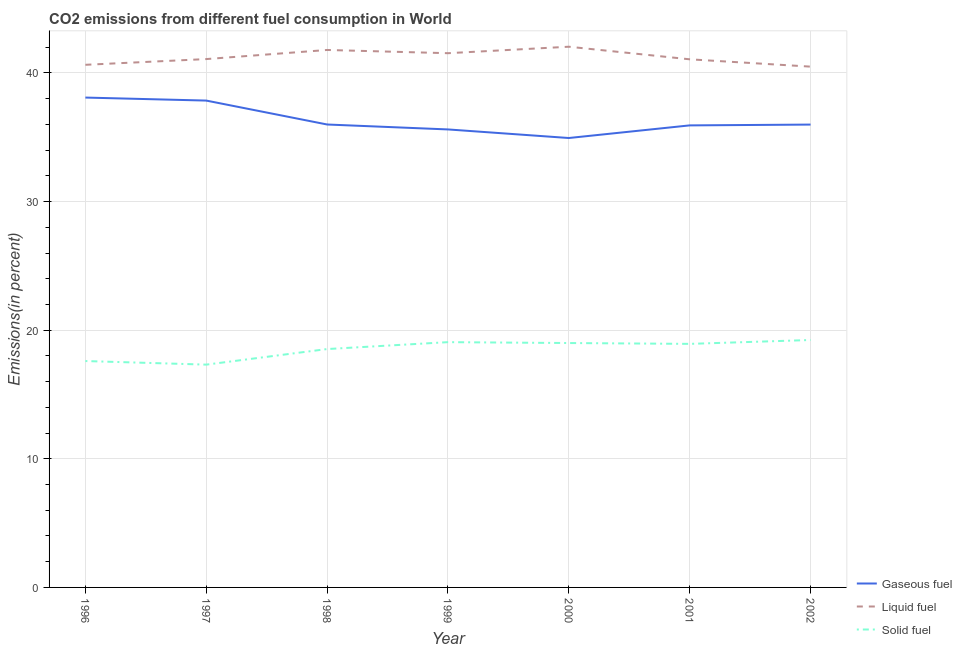What is the percentage of liquid fuel emission in 2000?
Offer a very short reply. 42.04. Across all years, what is the maximum percentage of gaseous fuel emission?
Provide a short and direct response. 38.08. Across all years, what is the minimum percentage of gaseous fuel emission?
Your answer should be compact. 34.94. What is the total percentage of gaseous fuel emission in the graph?
Provide a short and direct response. 254.38. What is the difference between the percentage of gaseous fuel emission in 2000 and that in 2002?
Keep it short and to the point. -1.04. What is the difference between the percentage of solid fuel emission in 1998 and the percentage of gaseous fuel emission in 2000?
Your answer should be compact. -16.41. What is the average percentage of gaseous fuel emission per year?
Provide a succinct answer. 36.34. In the year 1997, what is the difference between the percentage of gaseous fuel emission and percentage of liquid fuel emission?
Make the answer very short. -3.23. In how many years, is the percentage of liquid fuel emission greater than 32 %?
Provide a short and direct response. 7. What is the ratio of the percentage of gaseous fuel emission in 1999 to that in 2000?
Offer a very short reply. 1.02. Is the percentage of liquid fuel emission in 1996 less than that in 1997?
Make the answer very short. Yes. What is the difference between the highest and the second highest percentage of liquid fuel emission?
Provide a succinct answer. 0.25. What is the difference between the highest and the lowest percentage of gaseous fuel emission?
Your answer should be very brief. 3.14. In how many years, is the percentage of liquid fuel emission greater than the average percentage of liquid fuel emission taken over all years?
Your answer should be compact. 3. Is it the case that in every year, the sum of the percentage of gaseous fuel emission and percentage of liquid fuel emission is greater than the percentage of solid fuel emission?
Provide a short and direct response. Yes. Is the percentage of gaseous fuel emission strictly greater than the percentage of solid fuel emission over the years?
Make the answer very short. Yes. Is the percentage of liquid fuel emission strictly less than the percentage of solid fuel emission over the years?
Your response must be concise. No. How many years are there in the graph?
Provide a succinct answer. 7. Are the values on the major ticks of Y-axis written in scientific E-notation?
Give a very brief answer. No. Does the graph contain any zero values?
Your answer should be compact. No. Where does the legend appear in the graph?
Offer a very short reply. Bottom right. How are the legend labels stacked?
Keep it short and to the point. Vertical. What is the title of the graph?
Make the answer very short. CO2 emissions from different fuel consumption in World. Does "Unpaid family workers" appear as one of the legend labels in the graph?
Your answer should be very brief. No. What is the label or title of the X-axis?
Give a very brief answer. Year. What is the label or title of the Y-axis?
Offer a terse response. Emissions(in percent). What is the Emissions(in percent) in Gaseous fuel in 1996?
Offer a terse response. 38.08. What is the Emissions(in percent) of Liquid fuel in 1996?
Keep it short and to the point. 40.63. What is the Emissions(in percent) of Solid fuel in 1996?
Provide a succinct answer. 17.6. What is the Emissions(in percent) in Gaseous fuel in 1997?
Your answer should be very brief. 37.85. What is the Emissions(in percent) of Liquid fuel in 1997?
Provide a short and direct response. 41.08. What is the Emissions(in percent) in Solid fuel in 1997?
Make the answer very short. 17.32. What is the Emissions(in percent) in Gaseous fuel in 1998?
Keep it short and to the point. 35.99. What is the Emissions(in percent) in Liquid fuel in 1998?
Your answer should be compact. 41.79. What is the Emissions(in percent) in Solid fuel in 1998?
Ensure brevity in your answer.  18.53. What is the Emissions(in percent) of Gaseous fuel in 1999?
Make the answer very short. 35.61. What is the Emissions(in percent) of Liquid fuel in 1999?
Offer a terse response. 41.53. What is the Emissions(in percent) of Solid fuel in 1999?
Offer a very short reply. 19.07. What is the Emissions(in percent) in Gaseous fuel in 2000?
Your response must be concise. 34.94. What is the Emissions(in percent) of Liquid fuel in 2000?
Keep it short and to the point. 42.04. What is the Emissions(in percent) of Solid fuel in 2000?
Keep it short and to the point. 19. What is the Emissions(in percent) in Gaseous fuel in 2001?
Offer a terse response. 35.92. What is the Emissions(in percent) in Liquid fuel in 2001?
Your answer should be compact. 41.06. What is the Emissions(in percent) in Solid fuel in 2001?
Offer a very short reply. 18.93. What is the Emissions(in percent) in Gaseous fuel in 2002?
Keep it short and to the point. 35.98. What is the Emissions(in percent) in Liquid fuel in 2002?
Your answer should be compact. 40.49. What is the Emissions(in percent) in Solid fuel in 2002?
Offer a very short reply. 19.24. Across all years, what is the maximum Emissions(in percent) in Gaseous fuel?
Provide a succinct answer. 38.08. Across all years, what is the maximum Emissions(in percent) of Liquid fuel?
Ensure brevity in your answer.  42.04. Across all years, what is the maximum Emissions(in percent) of Solid fuel?
Your response must be concise. 19.24. Across all years, what is the minimum Emissions(in percent) of Gaseous fuel?
Your response must be concise. 34.94. Across all years, what is the minimum Emissions(in percent) in Liquid fuel?
Your response must be concise. 40.49. Across all years, what is the minimum Emissions(in percent) in Solid fuel?
Give a very brief answer. 17.32. What is the total Emissions(in percent) of Gaseous fuel in the graph?
Offer a terse response. 254.38. What is the total Emissions(in percent) of Liquid fuel in the graph?
Offer a terse response. 288.61. What is the total Emissions(in percent) in Solid fuel in the graph?
Ensure brevity in your answer.  129.7. What is the difference between the Emissions(in percent) in Gaseous fuel in 1996 and that in 1997?
Your response must be concise. 0.23. What is the difference between the Emissions(in percent) of Liquid fuel in 1996 and that in 1997?
Offer a very short reply. -0.45. What is the difference between the Emissions(in percent) of Solid fuel in 1996 and that in 1997?
Offer a very short reply. 0.28. What is the difference between the Emissions(in percent) of Gaseous fuel in 1996 and that in 1998?
Your response must be concise. 2.09. What is the difference between the Emissions(in percent) in Liquid fuel in 1996 and that in 1998?
Your answer should be compact. -1.15. What is the difference between the Emissions(in percent) in Solid fuel in 1996 and that in 1998?
Provide a succinct answer. -0.93. What is the difference between the Emissions(in percent) of Gaseous fuel in 1996 and that in 1999?
Your answer should be compact. 2.48. What is the difference between the Emissions(in percent) of Liquid fuel in 1996 and that in 1999?
Your answer should be compact. -0.9. What is the difference between the Emissions(in percent) in Solid fuel in 1996 and that in 1999?
Your answer should be very brief. -1.47. What is the difference between the Emissions(in percent) in Gaseous fuel in 1996 and that in 2000?
Your answer should be compact. 3.14. What is the difference between the Emissions(in percent) of Liquid fuel in 1996 and that in 2000?
Ensure brevity in your answer.  -1.41. What is the difference between the Emissions(in percent) in Gaseous fuel in 1996 and that in 2001?
Ensure brevity in your answer.  2.16. What is the difference between the Emissions(in percent) in Liquid fuel in 1996 and that in 2001?
Offer a very short reply. -0.43. What is the difference between the Emissions(in percent) of Solid fuel in 1996 and that in 2001?
Your response must be concise. -1.33. What is the difference between the Emissions(in percent) of Gaseous fuel in 1996 and that in 2002?
Give a very brief answer. 2.1. What is the difference between the Emissions(in percent) in Liquid fuel in 1996 and that in 2002?
Your answer should be compact. 0.14. What is the difference between the Emissions(in percent) of Solid fuel in 1996 and that in 2002?
Provide a succinct answer. -1.64. What is the difference between the Emissions(in percent) of Gaseous fuel in 1997 and that in 1998?
Your response must be concise. 1.86. What is the difference between the Emissions(in percent) in Liquid fuel in 1997 and that in 1998?
Make the answer very short. -0.71. What is the difference between the Emissions(in percent) of Solid fuel in 1997 and that in 1998?
Your answer should be compact. -1.21. What is the difference between the Emissions(in percent) of Gaseous fuel in 1997 and that in 1999?
Your answer should be compact. 2.24. What is the difference between the Emissions(in percent) in Liquid fuel in 1997 and that in 1999?
Ensure brevity in your answer.  -0.46. What is the difference between the Emissions(in percent) of Solid fuel in 1997 and that in 1999?
Keep it short and to the point. -1.75. What is the difference between the Emissions(in percent) in Gaseous fuel in 1997 and that in 2000?
Provide a succinct answer. 2.91. What is the difference between the Emissions(in percent) in Liquid fuel in 1997 and that in 2000?
Your answer should be very brief. -0.96. What is the difference between the Emissions(in percent) of Solid fuel in 1997 and that in 2000?
Your answer should be very brief. -1.68. What is the difference between the Emissions(in percent) of Gaseous fuel in 1997 and that in 2001?
Your response must be concise. 1.93. What is the difference between the Emissions(in percent) in Liquid fuel in 1997 and that in 2001?
Make the answer very short. 0.02. What is the difference between the Emissions(in percent) of Solid fuel in 1997 and that in 2001?
Your answer should be compact. -1.61. What is the difference between the Emissions(in percent) in Gaseous fuel in 1997 and that in 2002?
Provide a short and direct response. 1.87. What is the difference between the Emissions(in percent) in Liquid fuel in 1997 and that in 2002?
Offer a very short reply. 0.59. What is the difference between the Emissions(in percent) of Solid fuel in 1997 and that in 2002?
Give a very brief answer. -1.91. What is the difference between the Emissions(in percent) in Gaseous fuel in 1998 and that in 1999?
Your response must be concise. 0.38. What is the difference between the Emissions(in percent) of Liquid fuel in 1998 and that in 1999?
Your answer should be very brief. 0.25. What is the difference between the Emissions(in percent) in Solid fuel in 1998 and that in 1999?
Give a very brief answer. -0.54. What is the difference between the Emissions(in percent) in Gaseous fuel in 1998 and that in 2000?
Your answer should be very brief. 1.05. What is the difference between the Emissions(in percent) in Liquid fuel in 1998 and that in 2000?
Offer a terse response. -0.25. What is the difference between the Emissions(in percent) in Solid fuel in 1998 and that in 2000?
Offer a terse response. -0.47. What is the difference between the Emissions(in percent) in Gaseous fuel in 1998 and that in 2001?
Provide a short and direct response. 0.07. What is the difference between the Emissions(in percent) of Liquid fuel in 1998 and that in 2001?
Ensure brevity in your answer.  0.73. What is the difference between the Emissions(in percent) of Solid fuel in 1998 and that in 2001?
Offer a terse response. -0.4. What is the difference between the Emissions(in percent) in Gaseous fuel in 1998 and that in 2002?
Offer a terse response. 0.01. What is the difference between the Emissions(in percent) in Liquid fuel in 1998 and that in 2002?
Keep it short and to the point. 1.3. What is the difference between the Emissions(in percent) of Solid fuel in 1998 and that in 2002?
Ensure brevity in your answer.  -0.7. What is the difference between the Emissions(in percent) in Gaseous fuel in 1999 and that in 2000?
Offer a terse response. 0.67. What is the difference between the Emissions(in percent) of Liquid fuel in 1999 and that in 2000?
Provide a short and direct response. -0.5. What is the difference between the Emissions(in percent) in Solid fuel in 1999 and that in 2000?
Provide a short and direct response. 0.07. What is the difference between the Emissions(in percent) in Gaseous fuel in 1999 and that in 2001?
Offer a very short reply. -0.31. What is the difference between the Emissions(in percent) in Liquid fuel in 1999 and that in 2001?
Your answer should be compact. 0.47. What is the difference between the Emissions(in percent) of Solid fuel in 1999 and that in 2001?
Ensure brevity in your answer.  0.13. What is the difference between the Emissions(in percent) in Gaseous fuel in 1999 and that in 2002?
Provide a short and direct response. -0.38. What is the difference between the Emissions(in percent) of Liquid fuel in 1999 and that in 2002?
Give a very brief answer. 1.04. What is the difference between the Emissions(in percent) of Solid fuel in 1999 and that in 2002?
Your answer should be very brief. -0.17. What is the difference between the Emissions(in percent) in Gaseous fuel in 2000 and that in 2001?
Keep it short and to the point. -0.98. What is the difference between the Emissions(in percent) of Liquid fuel in 2000 and that in 2001?
Offer a terse response. 0.98. What is the difference between the Emissions(in percent) of Solid fuel in 2000 and that in 2001?
Your response must be concise. 0.07. What is the difference between the Emissions(in percent) of Gaseous fuel in 2000 and that in 2002?
Offer a very short reply. -1.04. What is the difference between the Emissions(in percent) in Liquid fuel in 2000 and that in 2002?
Your answer should be compact. 1.55. What is the difference between the Emissions(in percent) of Solid fuel in 2000 and that in 2002?
Offer a terse response. -0.24. What is the difference between the Emissions(in percent) in Gaseous fuel in 2001 and that in 2002?
Your response must be concise. -0.06. What is the difference between the Emissions(in percent) of Liquid fuel in 2001 and that in 2002?
Offer a terse response. 0.57. What is the difference between the Emissions(in percent) in Solid fuel in 2001 and that in 2002?
Your response must be concise. -0.3. What is the difference between the Emissions(in percent) in Gaseous fuel in 1996 and the Emissions(in percent) in Liquid fuel in 1997?
Give a very brief answer. -2.99. What is the difference between the Emissions(in percent) in Gaseous fuel in 1996 and the Emissions(in percent) in Solid fuel in 1997?
Provide a short and direct response. 20.76. What is the difference between the Emissions(in percent) in Liquid fuel in 1996 and the Emissions(in percent) in Solid fuel in 1997?
Make the answer very short. 23.31. What is the difference between the Emissions(in percent) in Gaseous fuel in 1996 and the Emissions(in percent) in Liquid fuel in 1998?
Your answer should be very brief. -3.7. What is the difference between the Emissions(in percent) of Gaseous fuel in 1996 and the Emissions(in percent) of Solid fuel in 1998?
Give a very brief answer. 19.55. What is the difference between the Emissions(in percent) of Liquid fuel in 1996 and the Emissions(in percent) of Solid fuel in 1998?
Offer a terse response. 22.1. What is the difference between the Emissions(in percent) of Gaseous fuel in 1996 and the Emissions(in percent) of Liquid fuel in 1999?
Keep it short and to the point. -3.45. What is the difference between the Emissions(in percent) of Gaseous fuel in 1996 and the Emissions(in percent) of Solid fuel in 1999?
Provide a short and direct response. 19.02. What is the difference between the Emissions(in percent) in Liquid fuel in 1996 and the Emissions(in percent) in Solid fuel in 1999?
Offer a terse response. 21.56. What is the difference between the Emissions(in percent) in Gaseous fuel in 1996 and the Emissions(in percent) in Liquid fuel in 2000?
Your response must be concise. -3.95. What is the difference between the Emissions(in percent) of Gaseous fuel in 1996 and the Emissions(in percent) of Solid fuel in 2000?
Give a very brief answer. 19.08. What is the difference between the Emissions(in percent) of Liquid fuel in 1996 and the Emissions(in percent) of Solid fuel in 2000?
Your response must be concise. 21.63. What is the difference between the Emissions(in percent) of Gaseous fuel in 1996 and the Emissions(in percent) of Liquid fuel in 2001?
Give a very brief answer. -2.97. What is the difference between the Emissions(in percent) in Gaseous fuel in 1996 and the Emissions(in percent) in Solid fuel in 2001?
Ensure brevity in your answer.  19.15. What is the difference between the Emissions(in percent) in Liquid fuel in 1996 and the Emissions(in percent) in Solid fuel in 2001?
Offer a terse response. 21.7. What is the difference between the Emissions(in percent) in Gaseous fuel in 1996 and the Emissions(in percent) in Liquid fuel in 2002?
Ensure brevity in your answer.  -2.4. What is the difference between the Emissions(in percent) in Gaseous fuel in 1996 and the Emissions(in percent) in Solid fuel in 2002?
Provide a succinct answer. 18.85. What is the difference between the Emissions(in percent) in Liquid fuel in 1996 and the Emissions(in percent) in Solid fuel in 2002?
Ensure brevity in your answer.  21.4. What is the difference between the Emissions(in percent) of Gaseous fuel in 1997 and the Emissions(in percent) of Liquid fuel in 1998?
Your answer should be very brief. -3.93. What is the difference between the Emissions(in percent) of Gaseous fuel in 1997 and the Emissions(in percent) of Solid fuel in 1998?
Offer a very short reply. 19.32. What is the difference between the Emissions(in percent) of Liquid fuel in 1997 and the Emissions(in percent) of Solid fuel in 1998?
Your answer should be compact. 22.54. What is the difference between the Emissions(in percent) of Gaseous fuel in 1997 and the Emissions(in percent) of Liquid fuel in 1999?
Offer a terse response. -3.68. What is the difference between the Emissions(in percent) in Gaseous fuel in 1997 and the Emissions(in percent) in Solid fuel in 1999?
Keep it short and to the point. 18.78. What is the difference between the Emissions(in percent) of Liquid fuel in 1997 and the Emissions(in percent) of Solid fuel in 1999?
Make the answer very short. 22.01. What is the difference between the Emissions(in percent) of Gaseous fuel in 1997 and the Emissions(in percent) of Liquid fuel in 2000?
Offer a terse response. -4.19. What is the difference between the Emissions(in percent) in Gaseous fuel in 1997 and the Emissions(in percent) in Solid fuel in 2000?
Provide a short and direct response. 18.85. What is the difference between the Emissions(in percent) of Liquid fuel in 1997 and the Emissions(in percent) of Solid fuel in 2000?
Give a very brief answer. 22.08. What is the difference between the Emissions(in percent) of Gaseous fuel in 1997 and the Emissions(in percent) of Liquid fuel in 2001?
Offer a very short reply. -3.21. What is the difference between the Emissions(in percent) in Gaseous fuel in 1997 and the Emissions(in percent) in Solid fuel in 2001?
Make the answer very short. 18.92. What is the difference between the Emissions(in percent) of Liquid fuel in 1997 and the Emissions(in percent) of Solid fuel in 2001?
Your response must be concise. 22.14. What is the difference between the Emissions(in percent) of Gaseous fuel in 1997 and the Emissions(in percent) of Liquid fuel in 2002?
Your answer should be compact. -2.64. What is the difference between the Emissions(in percent) of Gaseous fuel in 1997 and the Emissions(in percent) of Solid fuel in 2002?
Your answer should be very brief. 18.61. What is the difference between the Emissions(in percent) of Liquid fuel in 1997 and the Emissions(in percent) of Solid fuel in 2002?
Your response must be concise. 21.84. What is the difference between the Emissions(in percent) of Gaseous fuel in 1998 and the Emissions(in percent) of Liquid fuel in 1999?
Your answer should be compact. -5.54. What is the difference between the Emissions(in percent) in Gaseous fuel in 1998 and the Emissions(in percent) in Solid fuel in 1999?
Give a very brief answer. 16.92. What is the difference between the Emissions(in percent) of Liquid fuel in 1998 and the Emissions(in percent) of Solid fuel in 1999?
Provide a short and direct response. 22.72. What is the difference between the Emissions(in percent) of Gaseous fuel in 1998 and the Emissions(in percent) of Liquid fuel in 2000?
Your answer should be compact. -6.05. What is the difference between the Emissions(in percent) of Gaseous fuel in 1998 and the Emissions(in percent) of Solid fuel in 2000?
Your answer should be compact. 16.99. What is the difference between the Emissions(in percent) of Liquid fuel in 1998 and the Emissions(in percent) of Solid fuel in 2000?
Give a very brief answer. 22.78. What is the difference between the Emissions(in percent) of Gaseous fuel in 1998 and the Emissions(in percent) of Liquid fuel in 2001?
Make the answer very short. -5.07. What is the difference between the Emissions(in percent) of Gaseous fuel in 1998 and the Emissions(in percent) of Solid fuel in 2001?
Provide a succinct answer. 17.06. What is the difference between the Emissions(in percent) of Liquid fuel in 1998 and the Emissions(in percent) of Solid fuel in 2001?
Ensure brevity in your answer.  22.85. What is the difference between the Emissions(in percent) in Gaseous fuel in 1998 and the Emissions(in percent) in Liquid fuel in 2002?
Your response must be concise. -4.5. What is the difference between the Emissions(in percent) in Gaseous fuel in 1998 and the Emissions(in percent) in Solid fuel in 2002?
Your response must be concise. 16.75. What is the difference between the Emissions(in percent) in Liquid fuel in 1998 and the Emissions(in percent) in Solid fuel in 2002?
Your response must be concise. 22.55. What is the difference between the Emissions(in percent) of Gaseous fuel in 1999 and the Emissions(in percent) of Liquid fuel in 2000?
Ensure brevity in your answer.  -6.43. What is the difference between the Emissions(in percent) of Gaseous fuel in 1999 and the Emissions(in percent) of Solid fuel in 2000?
Give a very brief answer. 16.61. What is the difference between the Emissions(in percent) of Liquid fuel in 1999 and the Emissions(in percent) of Solid fuel in 2000?
Give a very brief answer. 22.53. What is the difference between the Emissions(in percent) of Gaseous fuel in 1999 and the Emissions(in percent) of Liquid fuel in 2001?
Provide a succinct answer. -5.45. What is the difference between the Emissions(in percent) in Gaseous fuel in 1999 and the Emissions(in percent) in Solid fuel in 2001?
Keep it short and to the point. 16.67. What is the difference between the Emissions(in percent) of Liquid fuel in 1999 and the Emissions(in percent) of Solid fuel in 2001?
Provide a short and direct response. 22.6. What is the difference between the Emissions(in percent) in Gaseous fuel in 1999 and the Emissions(in percent) in Liquid fuel in 2002?
Provide a short and direct response. -4.88. What is the difference between the Emissions(in percent) in Gaseous fuel in 1999 and the Emissions(in percent) in Solid fuel in 2002?
Provide a succinct answer. 16.37. What is the difference between the Emissions(in percent) in Liquid fuel in 1999 and the Emissions(in percent) in Solid fuel in 2002?
Offer a terse response. 22.3. What is the difference between the Emissions(in percent) of Gaseous fuel in 2000 and the Emissions(in percent) of Liquid fuel in 2001?
Your answer should be very brief. -6.12. What is the difference between the Emissions(in percent) in Gaseous fuel in 2000 and the Emissions(in percent) in Solid fuel in 2001?
Your response must be concise. 16.01. What is the difference between the Emissions(in percent) in Liquid fuel in 2000 and the Emissions(in percent) in Solid fuel in 2001?
Your response must be concise. 23.1. What is the difference between the Emissions(in percent) in Gaseous fuel in 2000 and the Emissions(in percent) in Liquid fuel in 2002?
Give a very brief answer. -5.55. What is the difference between the Emissions(in percent) of Gaseous fuel in 2000 and the Emissions(in percent) of Solid fuel in 2002?
Your answer should be very brief. 15.7. What is the difference between the Emissions(in percent) of Liquid fuel in 2000 and the Emissions(in percent) of Solid fuel in 2002?
Your answer should be very brief. 22.8. What is the difference between the Emissions(in percent) in Gaseous fuel in 2001 and the Emissions(in percent) in Liquid fuel in 2002?
Make the answer very short. -4.57. What is the difference between the Emissions(in percent) of Gaseous fuel in 2001 and the Emissions(in percent) of Solid fuel in 2002?
Offer a terse response. 16.69. What is the difference between the Emissions(in percent) in Liquid fuel in 2001 and the Emissions(in percent) in Solid fuel in 2002?
Provide a succinct answer. 21.82. What is the average Emissions(in percent) in Gaseous fuel per year?
Provide a succinct answer. 36.34. What is the average Emissions(in percent) of Liquid fuel per year?
Offer a terse response. 41.23. What is the average Emissions(in percent) in Solid fuel per year?
Offer a terse response. 18.53. In the year 1996, what is the difference between the Emissions(in percent) of Gaseous fuel and Emissions(in percent) of Liquid fuel?
Your answer should be very brief. -2.55. In the year 1996, what is the difference between the Emissions(in percent) in Gaseous fuel and Emissions(in percent) in Solid fuel?
Offer a very short reply. 20.48. In the year 1996, what is the difference between the Emissions(in percent) in Liquid fuel and Emissions(in percent) in Solid fuel?
Make the answer very short. 23.03. In the year 1997, what is the difference between the Emissions(in percent) in Gaseous fuel and Emissions(in percent) in Liquid fuel?
Make the answer very short. -3.23. In the year 1997, what is the difference between the Emissions(in percent) in Gaseous fuel and Emissions(in percent) in Solid fuel?
Keep it short and to the point. 20.53. In the year 1997, what is the difference between the Emissions(in percent) of Liquid fuel and Emissions(in percent) of Solid fuel?
Make the answer very short. 23.76. In the year 1998, what is the difference between the Emissions(in percent) in Gaseous fuel and Emissions(in percent) in Liquid fuel?
Offer a terse response. -5.79. In the year 1998, what is the difference between the Emissions(in percent) of Gaseous fuel and Emissions(in percent) of Solid fuel?
Ensure brevity in your answer.  17.46. In the year 1998, what is the difference between the Emissions(in percent) in Liquid fuel and Emissions(in percent) in Solid fuel?
Ensure brevity in your answer.  23.25. In the year 1999, what is the difference between the Emissions(in percent) of Gaseous fuel and Emissions(in percent) of Liquid fuel?
Ensure brevity in your answer.  -5.93. In the year 1999, what is the difference between the Emissions(in percent) of Gaseous fuel and Emissions(in percent) of Solid fuel?
Provide a short and direct response. 16.54. In the year 1999, what is the difference between the Emissions(in percent) in Liquid fuel and Emissions(in percent) in Solid fuel?
Offer a terse response. 22.46. In the year 2000, what is the difference between the Emissions(in percent) in Gaseous fuel and Emissions(in percent) in Liquid fuel?
Provide a succinct answer. -7.1. In the year 2000, what is the difference between the Emissions(in percent) in Gaseous fuel and Emissions(in percent) in Solid fuel?
Make the answer very short. 15.94. In the year 2000, what is the difference between the Emissions(in percent) of Liquid fuel and Emissions(in percent) of Solid fuel?
Offer a very short reply. 23.04. In the year 2001, what is the difference between the Emissions(in percent) in Gaseous fuel and Emissions(in percent) in Liquid fuel?
Your response must be concise. -5.14. In the year 2001, what is the difference between the Emissions(in percent) of Gaseous fuel and Emissions(in percent) of Solid fuel?
Your answer should be very brief. 16.99. In the year 2001, what is the difference between the Emissions(in percent) in Liquid fuel and Emissions(in percent) in Solid fuel?
Keep it short and to the point. 22.12. In the year 2002, what is the difference between the Emissions(in percent) in Gaseous fuel and Emissions(in percent) in Liquid fuel?
Ensure brevity in your answer.  -4.51. In the year 2002, what is the difference between the Emissions(in percent) of Gaseous fuel and Emissions(in percent) of Solid fuel?
Ensure brevity in your answer.  16.75. In the year 2002, what is the difference between the Emissions(in percent) of Liquid fuel and Emissions(in percent) of Solid fuel?
Keep it short and to the point. 21.25. What is the ratio of the Emissions(in percent) in Gaseous fuel in 1996 to that in 1997?
Offer a very short reply. 1.01. What is the ratio of the Emissions(in percent) of Solid fuel in 1996 to that in 1997?
Your answer should be very brief. 1.02. What is the ratio of the Emissions(in percent) in Gaseous fuel in 1996 to that in 1998?
Your response must be concise. 1.06. What is the ratio of the Emissions(in percent) of Liquid fuel in 1996 to that in 1998?
Your response must be concise. 0.97. What is the ratio of the Emissions(in percent) in Solid fuel in 1996 to that in 1998?
Keep it short and to the point. 0.95. What is the ratio of the Emissions(in percent) in Gaseous fuel in 1996 to that in 1999?
Make the answer very short. 1.07. What is the ratio of the Emissions(in percent) in Liquid fuel in 1996 to that in 1999?
Offer a terse response. 0.98. What is the ratio of the Emissions(in percent) of Solid fuel in 1996 to that in 1999?
Provide a short and direct response. 0.92. What is the ratio of the Emissions(in percent) in Gaseous fuel in 1996 to that in 2000?
Provide a succinct answer. 1.09. What is the ratio of the Emissions(in percent) in Liquid fuel in 1996 to that in 2000?
Your answer should be very brief. 0.97. What is the ratio of the Emissions(in percent) in Solid fuel in 1996 to that in 2000?
Provide a succinct answer. 0.93. What is the ratio of the Emissions(in percent) in Gaseous fuel in 1996 to that in 2001?
Your answer should be compact. 1.06. What is the ratio of the Emissions(in percent) of Liquid fuel in 1996 to that in 2001?
Your response must be concise. 0.99. What is the ratio of the Emissions(in percent) of Solid fuel in 1996 to that in 2001?
Your response must be concise. 0.93. What is the ratio of the Emissions(in percent) of Gaseous fuel in 1996 to that in 2002?
Your answer should be very brief. 1.06. What is the ratio of the Emissions(in percent) of Solid fuel in 1996 to that in 2002?
Provide a succinct answer. 0.92. What is the ratio of the Emissions(in percent) in Gaseous fuel in 1997 to that in 1998?
Offer a terse response. 1.05. What is the ratio of the Emissions(in percent) of Liquid fuel in 1997 to that in 1998?
Your answer should be compact. 0.98. What is the ratio of the Emissions(in percent) of Solid fuel in 1997 to that in 1998?
Offer a terse response. 0.93. What is the ratio of the Emissions(in percent) of Gaseous fuel in 1997 to that in 1999?
Give a very brief answer. 1.06. What is the ratio of the Emissions(in percent) in Solid fuel in 1997 to that in 1999?
Your response must be concise. 0.91. What is the ratio of the Emissions(in percent) of Gaseous fuel in 1997 to that in 2000?
Keep it short and to the point. 1.08. What is the ratio of the Emissions(in percent) of Liquid fuel in 1997 to that in 2000?
Ensure brevity in your answer.  0.98. What is the ratio of the Emissions(in percent) in Solid fuel in 1997 to that in 2000?
Your response must be concise. 0.91. What is the ratio of the Emissions(in percent) in Gaseous fuel in 1997 to that in 2001?
Offer a terse response. 1.05. What is the ratio of the Emissions(in percent) of Liquid fuel in 1997 to that in 2001?
Your answer should be compact. 1. What is the ratio of the Emissions(in percent) in Solid fuel in 1997 to that in 2001?
Your answer should be very brief. 0.91. What is the ratio of the Emissions(in percent) of Gaseous fuel in 1997 to that in 2002?
Offer a terse response. 1.05. What is the ratio of the Emissions(in percent) of Liquid fuel in 1997 to that in 2002?
Make the answer very short. 1.01. What is the ratio of the Emissions(in percent) in Solid fuel in 1997 to that in 2002?
Give a very brief answer. 0.9. What is the ratio of the Emissions(in percent) of Gaseous fuel in 1998 to that in 1999?
Make the answer very short. 1.01. What is the ratio of the Emissions(in percent) in Solid fuel in 1998 to that in 1999?
Your response must be concise. 0.97. What is the ratio of the Emissions(in percent) in Gaseous fuel in 1998 to that in 2000?
Give a very brief answer. 1.03. What is the ratio of the Emissions(in percent) of Solid fuel in 1998 to that in 2000?
Provide a succinct answer. 0.98. What is the ratio of the Emissions(in percent) of Liquid fuel in 1998 to that in 2001?
Offer a very short reply. 1.02. What is the ratio of the Emissions(in percent) of Solid fuel in 1998 to that in 2001?
Provide a succinct answer. 0.98. What is the ratio of the Emissions(in percent) in Liquid fuel in 1998 to that in 2002?
Your answer should be very brief. 1.03. What is the ratio of the Emissions(in percent) in Solid fuel in 1998 to that in 2002?
Offer a very short reply. 0.96. What is the ratio of the Emissions(in percent) of Gaseous fuel in 1999 to that in 2000?
Offer a terse response. 1.02. What is the ratio of the Emissions(in percent) in Liquid fuel in 1999 to that in 2000?
Keep it short and to the point. 0.99. What is the ratio of the Emissions(in percent) in Gaseous fuel in 1999 to that in 2001?
Give a very brief answer. 0.99. What is the ratio of the Emissions(in percent) of Liquid fuel in 1999 to that in 2001?
Your answer should be compact. 1.01. What is the ratio of the Emissions(in percent) of Solid fuel in 1999 to that in 2001?
Your response must be concise. 1.01. What is the ratio of the Emissions(in percent) in Gaseous fuel in 1999 to that in 2002?
Your answer should be very brief. 0.99. What is the ratio of the Emissions(in percent) of Liquid fuel in 1999 to that in 2002?
Keep it short and to the point. 1.03. What is the ratio of the Emissions(in percent) in Solid fuel in 1999 to that in 2002?
Your answer should be compact. 0.99. What is the ratio of the Emissions(in percent) in Gaseous fuel in 2000 to that in 2001?
Provide a short and direct response. 0.97. What is the ratio of the Emissions(in percent) in Liquid fuel in 2000 to that in 2001?
Your response must be concise. 1.02. What is the ratio of the Emissions(in percent) in Liquid fuel in 2000 to that in 2002?
Make the answer very short. 1.04. What is the ratio of the Emissions(in percent) in Liquid fuel in 2001 to that in 2002?
Keep it short and to the point. 1.01. What is the ratio of the Emissions(in percent) in Solid fuel in 2001 to that in 2002?
Offer a very short reply. 0.98. What is the difference between the highest and the second highest Emissions(in percent) of Gaseous fuel?
Your answer should be compact. 0.23. What is the difference between the highest and the second highest Emissions(in percent) of Liquid fuel?
Your answer should be compact. 0.25. What is the difference between the highest and the second highest Emissions(in percent) in Solid fuel?
Your answer should be compact. 0.17. What is the difference between the highest and the lowest Emissions(in percent) of Gaseous fuel?
Keep it short and to the point. 3.14. What is the difference between the highest and the lowest Emissions(in percent) of Liquid fuel?
Your answer should be very brief. 1.55. What is the difference between the highest and the lowest Emissions(in percent) of Solid fuel?
Provide a short and direct response. 1.91. 